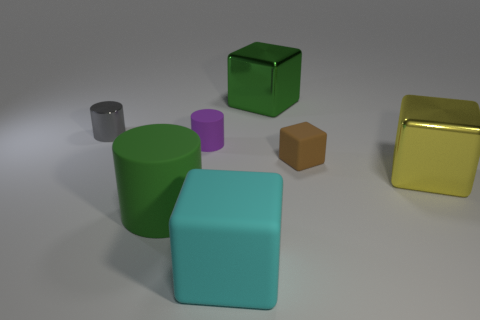There is a big cylinder; is it the same color as the metal block behind the small rubber cylinder?
Provide a short and direct response. Yes. There is a purple cylinder that is made of the same material as the tiny brown cube; what is its size?
Provide a short and direct response. Small. Are there any large shiny blocks that have the same color as the big cylinder?
Ensure brevity in your answer.  Yes. What number of objects are rubber things to the right of the small purple cylinder or cyan matte blocks?
Your answer should be very brief. 2. Do the large green cylinder and the tiny cylinder behind the purple matte cylinder have the same material?
Your answer should be very brief. No. The object that is the same color as the large rubber cylinder is what size?
Ensure brevity in your answer.  Large. Is there a green cylinder that has the same material as the brown block?
Keep it short and to the point. Yes. What number of things are either big rubber things behind the cyan cube or big shiny things that are in front of the brown matte cube?
Provide a succinct answer. 2. Do the small purple matte object and the object that is right of the small cube have the same shape?
Make the answer very short. No. How many other things are the same shape as the cyan thing?
Your answer should be compact. 3. 